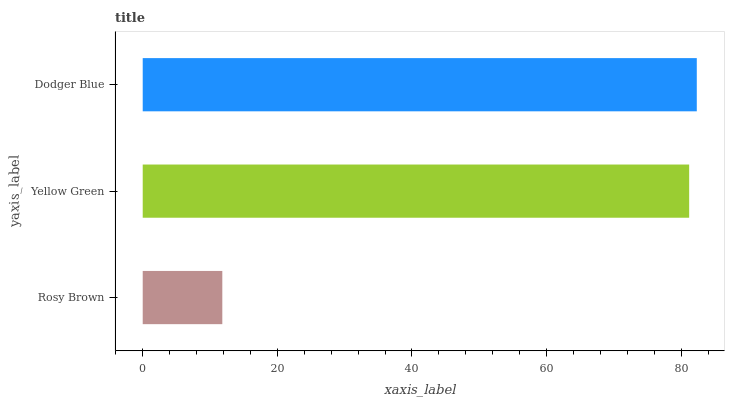Is Rosy Brown the minimum?
Answer yes or no. Yes. Is Dodger Blue the maximum?
Answer yes or no. Yes. Is Yellow Green the minimum?
Answer yes or no. No. Is Yellow Green the maximum?
Answer yes or no. No. Is Yellow Green greater than Rosy Brown?
Answer yes or no. Yes. Is Rosy Brown less than Yellow Green?
Answer yes or no. Yes. Is Rosy Brown greater than Yellow Green?
Answer yes or no. No. Is Yellow Green less than Rosy Brown?
Answer yes or no. No. Is Yellow Green the high median?
Answer yes or no. Yes. Is Yellow Green the low median?
Answer yes or no. Yes. Is Dodger Blue the high median?
Answer yes or no. No. Is Rosy Brown the low median?
Answer yes or no. No. 